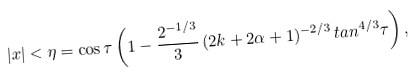Convert formula to latex. <formula><loc_0><loc_0><loc_500><loc_500>| x | < \eta = \cos \tau \left ( 1 - \frac { 2 ^ { - 1 / 3 } } { 3 } \, ( 2 k + 2 \alpha + 1 ) ^ { - 2 / 3 } \, t a n ^ { 4 / 3 } \tau \right ) ,</formula> 